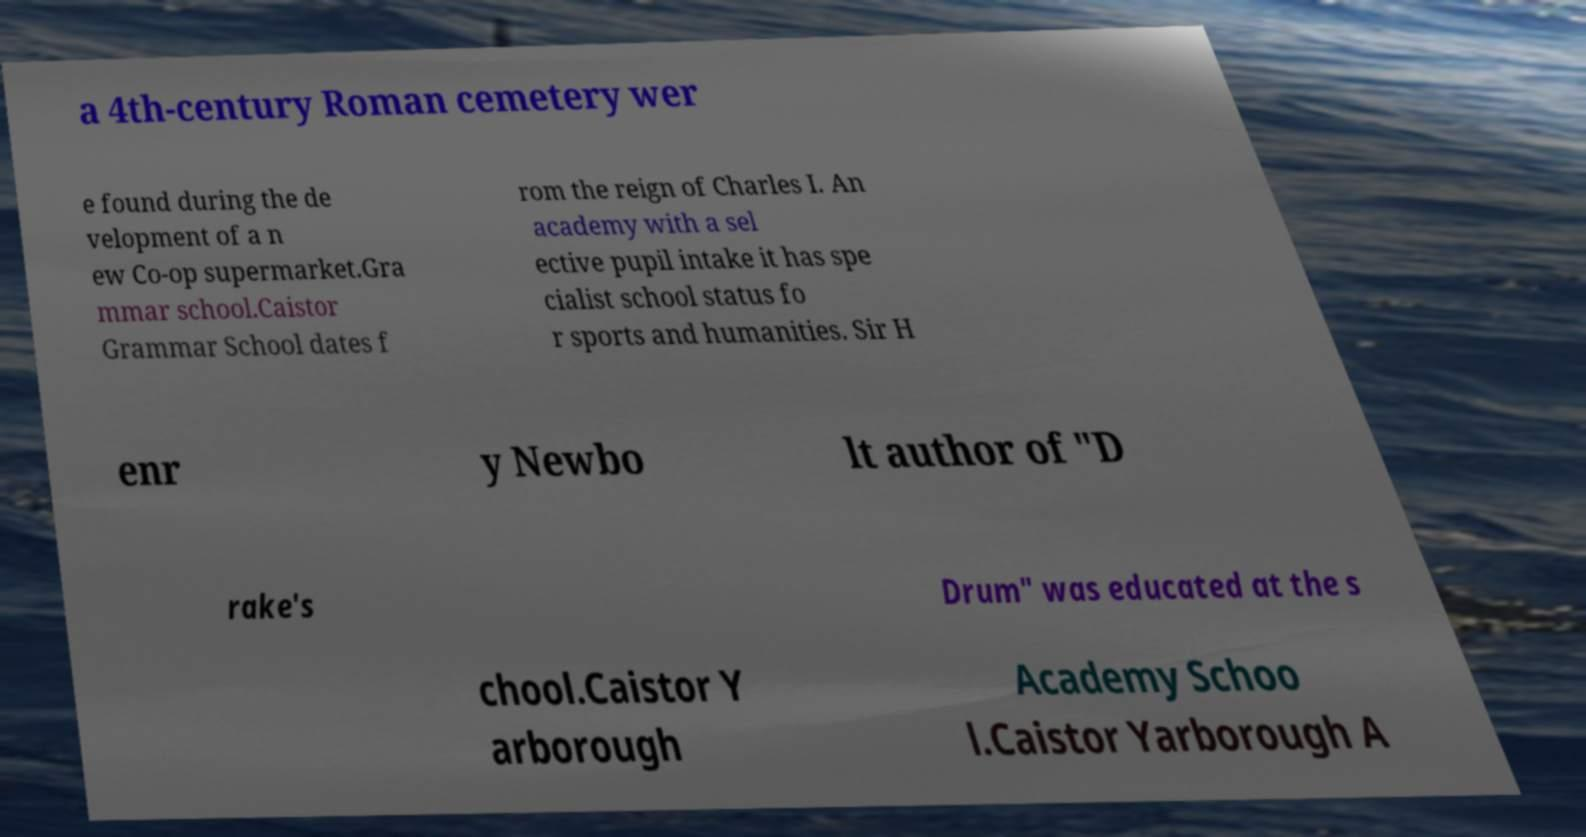Please read and relay the text visible in this image. What does it say? a 4th-century Roman cemetery wer e found during the de velopment of a n ew Co-op supermarket.Gra mmar school.Caistor Grammar School dates f rom the reign of Charles I. An academy with a sel ective pupil intake it has spe cialist school status fo r sports and humanities. Sir H enr y Newbo lt author of "D rake's Drum" was educated at the s chool.Caistor Y arborough Academy Schoo l.Caistor Yarborough A 